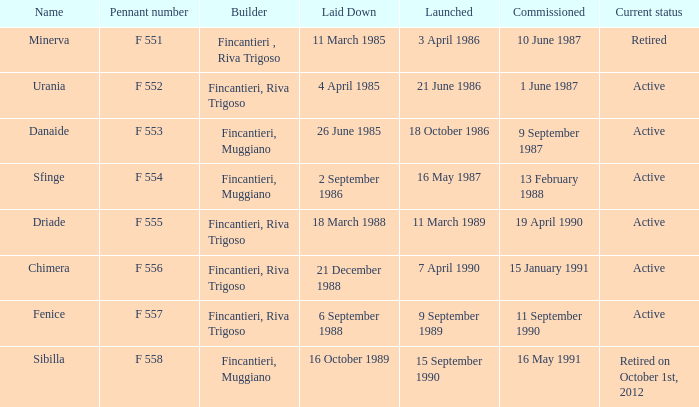Can you parse all the data within this table? {'header': ['Name', 'Pennant number', 'Builder', 'Laid Down', 'Launched', 'Commissioned', 'Current status'], 'rows': [['Minerva', 'F 551', 'Fincantieri , Riva Trigoso', '11 March 1985', '3 April 1986', '10 June 1987', 'Retired'], ['Urania', 'F 552', 'Fincantieri, Riva Trigoso', '4 April 1985', '21 June 1986', '1 June 1987', 'Active'], ['Danaide', 'F 553', 'Fincantieri, Muggiano', '26 June 1985', '18 October 1986', '9 September 1987', 'Active'], ['Sfinge', 'F 554', 'Fincantieri, Muggiano', '2 September 1986', '16 May 1987', '13 February 1988', 'Active'], ['Driade', 'F 555', 'Fincantieri, Riva Trigoso', '18 March 1988', '11 March 1989', '19 April 1990', 'Active'], ['Chimera', 'F 556', 'Fincantieri, Riva Trigoso', '21 December 1988', '7 April 1990', '15 January 1991', 'Active'], ['Fenice', 'F 557', 'Fincantieri, Riva Trigoso', '6 September 1988', '9 September 1989', '11 September 1990', 'Active'], ['Sibilla', 'F 558', 'Fincantieri, Muggiano', '16 October 1989', '15 September 1990', '16 May 1991', 'Retired on October 1st, 2012']]} What builder is now retired F 551. 